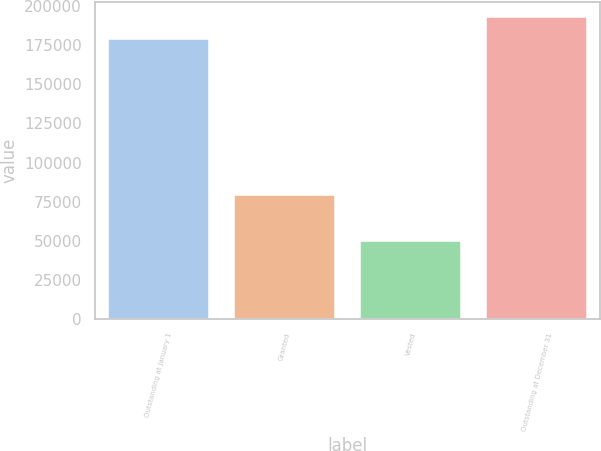<chart> <loc_0><loc_0><loc_500><loc_500><bar_chart><fcel>Outstanding at January 1<fcel>Granted<fcel>Vested<fcel>Outstanding at December 31<nl><fcel>179300<fcel>79500<fcel>49510<fcel>193208<nl></chart> 